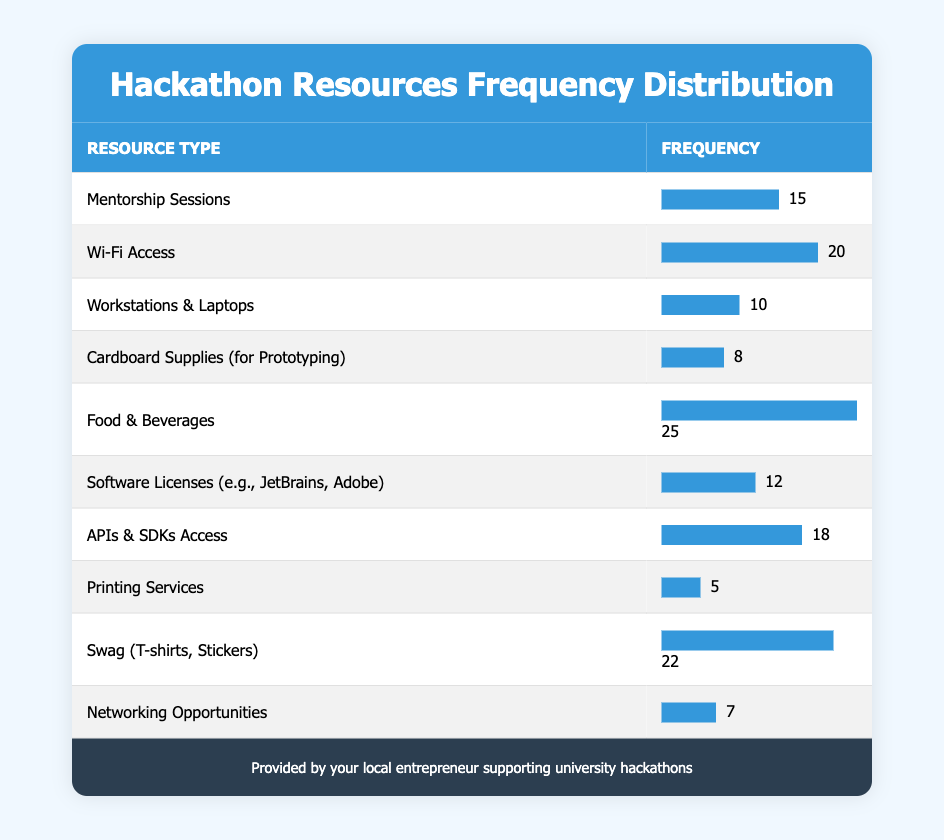What resource type has the highest frequency provided at the hackathons? The table lists the resources and their frequencies. Scanning through the frequency column, the highest frequency is 25, which corresponds to "Food & Beverages."
Answer: Food & Beverages How many resources have a frequency of 15 or more? To determine this, we count all rows with a frequency column value of 15 or higher. The qualifying resources are "Mentorship Sessions" (15), "Wi-Fi Access" (20), "Food & Beverages" (25), "APIs & SDKs Access" (18), "Swag (T-shirts, Stickers)" (22). That totals to 5 resources.
Answer: 5 Is Wi-Fi Access provided more frequently than Software Licenses? We compare the frequencies of "Wi-Fi Access" (20) and "Software Licenses" (12). Since 20 is greater than 12, the statement is true.
Answer: Yes What is the total frequency of resources related to prototyping? The only resource related to prototyping is "Cardboard Supplies," which has a frequency of 8. We note that this is the only entry, so the total frequency here is simply 8.
Answer: 8 What is the average frequency of all resources listed? To find the average, we sum all frequency values: 15 + 20 + 10 + 8 + 25 + 12 + 18 + 5 + 22 + 7 =  142. Then, we divide this sum by the number of resources (10): 142 / 10 = 14.2.
Answer: 14.2 Which resource has the lowest frequency and how many are provided? The resource with the lowest frequency is "Printing Services," which has a frequency of 5. Upon checking the table, this is confirmed.
Answer: Printing Services, 5 Are there more resources offering networking opportunities or printing services? "Networking Opportunities" has a frequency of 7, while "Printing Services" has a frequency of 5. Since 7 is greater than 5, there are indeed more resources for networking opportunities.
Answer: Yes How many more frequencies are there for food compared to swag? The frequency for "Food & Beverages" is 25 and for "Swag" it is 22. We find the difference: 25 - 22 = 3.
Answer: 3 Which resource type has a frequency between 10 and 20? We check the table for resource types whose frequency values fall between 10 and 20. The qualifying resources are "Wi-Fi Access" (20), "Software Licenses" (12), and "APIs & SDKs Access" (18). This totals to 3 resources.
Answer: 3 